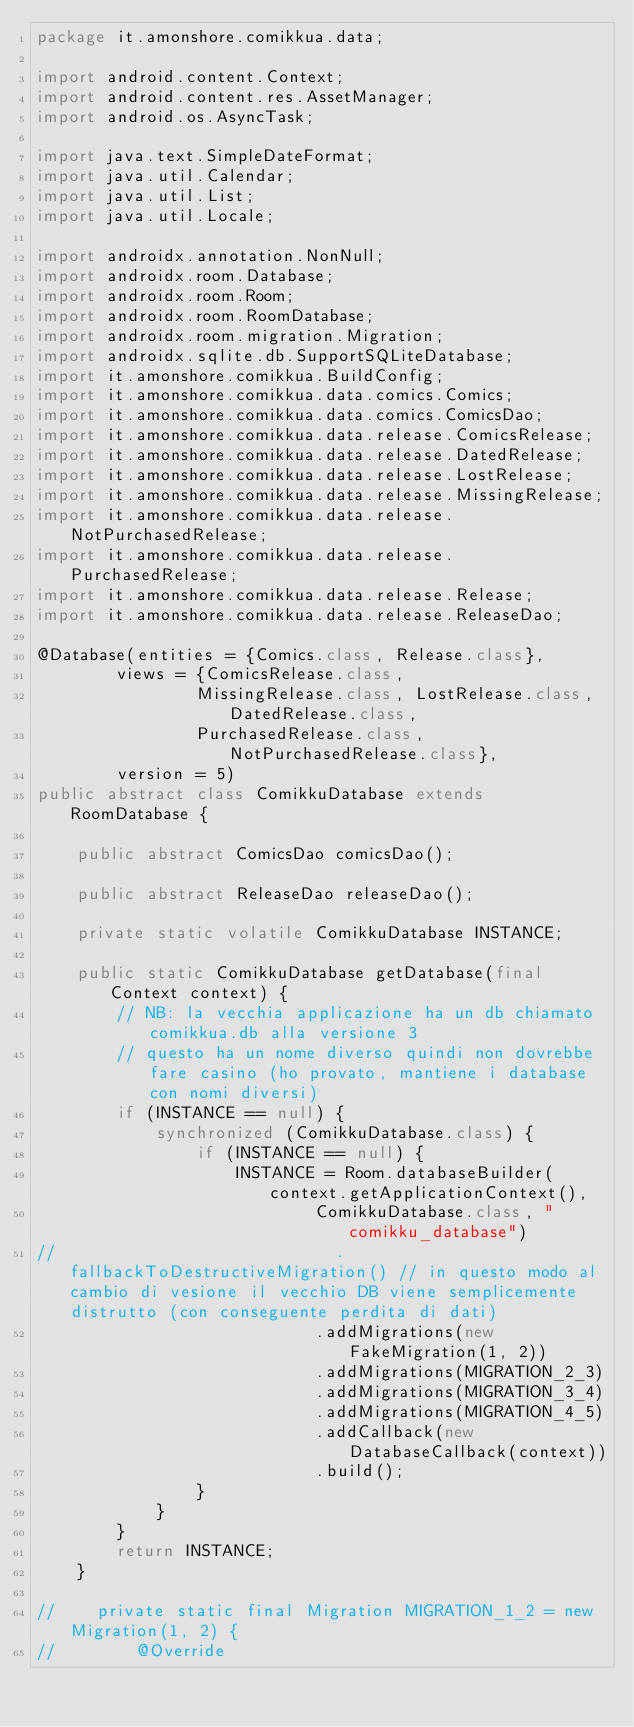Convert code to text. <code><loc_0><loc_0><loc_500><loc_500><_Java_>package it.amonshore.comikkua.data;

import android.content.Context;
import android.content.res.AssetManager;
import android.os.AsyncTask;

import java.text.SimpleDateFormat;
import java.util.Calendar;
import java.util.List;
import java.util.Locale;

import androidx.annotation.NonNull;
import androidx.room.Database;
import androidx.room.Room;
import androidx.room.RoomDatabase;
import androidx.room.migration.Migration;
import androidx.sqlite.db.SupportSQLiteDatabase;
import it.amonshore.comikkua.BuildConfig;
import it.amonshore.comikkua.data.comics.Comics;
import it.amonshore.comikkua.data.comics.ComicsDao;
import it.amonshore.comikkua.data.release.ComicsRelease;
import it.amonshore.comikkua.data.release.DatedRelease;
import it.amonshore.comikkua.data.release.LostRelease;
import it.amonshore.comikkua.data.release.MissingRelease;
import it.amonshore.comikkua.data.release.NotPurchasedRelease;
import it.amonshore.comikkua.data.release.PurchasedRelease;
import it.amonshore.comikkua.data.release.Release;
import it.amonshore.comikkua.data.release.ReleaseDao;

@Database(entities = {Comics.class, Release.class},
        views = {ComicsRelease.class,
                MissingRelease.class, LostRelease.class, DatedRelease.class,
                PurchasedRelease.class, NotPurchasedRelease.class},
        version = 5)
public abstract class ComikkuDatabase extends RoomDatabase {

    public abstract ComicsDao comicsDao();

    public abstract ReleaseDao releaseDao();

    private static volatile ComikkuDatabase INSTANCE;

    public static ComikkuDatabase getDatabase(final Context context) {
        // NB: la vecchia applicazione ha un db chiamato comikkua.db alla versione 3
        // questo ha un nome diverso quindi non dovrebbe fare casino (ho provato, mantiene i database con nomi diversi)
        if (INSTANCE == null) {
            synchronized (ComikkuDatabase.class) {
                if (INSTANCE == null) {
                    INSTANCE = Room.databaseBuilder(context.getApplicationContext(),
                            ComikkuDatabase.class, "comikku_database")
//                            .fallbackToDestructiveMigration() // in questo modo al cambio di vesione il vecchio DB viene semplicemente distrutto (con conseguente perdita di dati)
                            .addMigrations(new FakeMigration(1, 2))
                            .addMigrations(MIGRATION_2_3)
                            .addMigrations(MIGRATION_3_4)
                            .addMigrations(MIGRATION_4_5)
                            .addCallback(new DatabaseCallback(context))
                            .build();
                }
            }
        }
        return INSTANCE;
    }

//    private static final Migration MIGRATION_1_2 = new Migration(1, 2) {
//        @Override</code> 